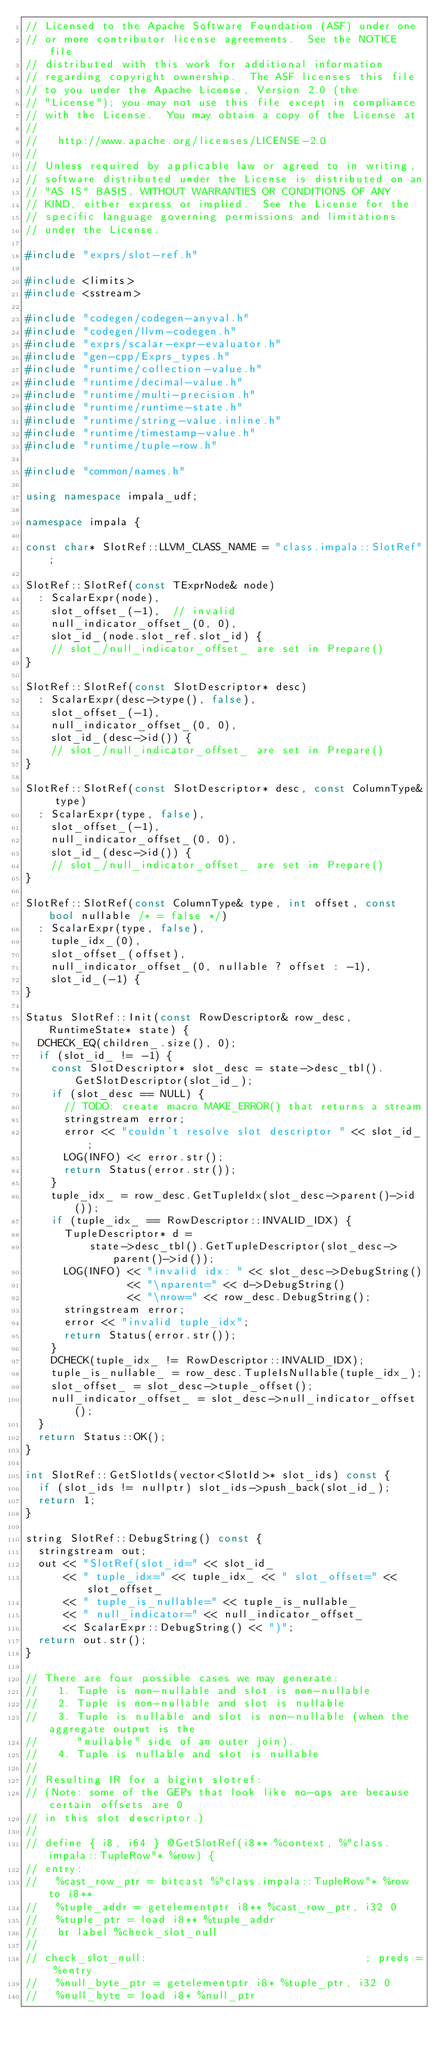<code> <loc_0><loc_0><loc_500><loc_500><_C++_>// Licensed to the Apache Software Foundation (ASF) under one
// or more contributor license agreements.  See the NOTICE file
// distributed with this work for additional information
// regarding copyright ownership.  The ASF licenses this file
// to you under the Apache License, Version 2.0 (the
// "License"); you may not use this file except in compliance
// with the License.  You may obtain a copy of the License at
//
//   http://www.apache.org/licenses/LICENSE-2.0
//
// Unless required by applicable law or agreed to in writing,
// software distributed under the License is distributed on an
// "AS IS" BASIS, WITHOUT WARRANTIES OR CONDITIONS OF ANY
// KIND, either express or implied.  See the License for the
// specific language governing permissions and limitations
// under the License.

#include "exprs/slot-ref.h"

#include <limits>
#include <sstream>

#include "codegen/codegen-anyval.h"
#include "codegen/llvm-codegen.h"
#include "exprs/scalar-expr-evaluator.h"
#include "gen-cpp/Exprs_types.h"
#include "runtime/collection-value.h"
#include "runtime/decimal-value.h"
#include "runtime/multi-precision.h"
#include "runtime/runtime-state.h"
#include "runtime/string-value.inline.h"
#include "runtime/timestamp-value.h"
#include "runtime/tuple-row.h"

#include "common/names.h"

using namespace impala_udf;

namespace impala {

const char* SlotRef::LLVM_CLASS_NAME = "class.impala::SlotRef";

SlotRef::SlotRef(const TExprNode& node)
  : ScalarExpr(node),
    slot_offset_(-1),  // invalid
    null_indicator_offset_(0, 0),
    slot_id_(node.slot_ref.slot_id) {
    // slot_/null_indicator_offset_ are set in Prepare()
}

SlotRef::SlotRef(const SlotDescriptor* desc)
  : ScalarExpr(desc->type(), false),
    slot_offset_(-1),
    null_indicator_offset_(0, 0),
    slot_id_(desc->id()) {
    // slot_/null_indicator_offset_ are set in Prepare()
}

SlotRef::SlotRef(const SlotDescriptor* desc, const ColumnType& type)
  : ScalarExpr(type, false),
    slot_offset_(-1),
    null_indicator_offset_(0, 0),
    slot_id_(desc->id()) {
    // slot_/null_indicator_offset_ are set in Prepare()
}

SlotRef::SlotRef(const ColumnType& type, int offset, const bool nullable /* = false */)
  : ScalarExpr(type, false),
    tuple_idx_(0),
    slot_offset_(offset),
    null_indicator_offset_(0, nullable ? offset : -1),
    slot_id_(-1) {
}

Status SlotRef::Init(const RowDescriptor& row_desc, RuntimeState* state) {
  DCHECK_EQ(children_.size(), 0);
  if (slot_id_ != -1) {
    const SlotDescriptor* slot_desc = state->desc_tbl().GetSlotDescriptor(slot_id_);
    if (slot_desc == NULL) {
      // TODO: create macro MAKE_ERROR() that returns a stream
      stringstream error;
      error << "couldn't resolve slot descriptor " << slot_id_;
      LOG(INFO) << error.str();
      return Status(error.str());
    }
    tuple_idx_ = row_desc.GetTupleIdx(slot_desc->parent()->id());
    if (tuple_idx_ == RowDescriptor::INVALID_IDX) {
      TupleDescriptor* d =
          state->desc_tbl().GetTupleDescriptor(slot_desc->parent()->id());
      LOG(INFO) << "invalid idx: " << slot_desc->DebugString()
                << "\nparent=" << d->DebugString()
                << "\nrow=" << row_desc.DebugString();
      stringstream error;
      error << "invalid tuple_idx";
      return Status(error.str());
    }
    DCHECK(tuple_idx_ != RowDescriptor::INVALID_IDX);
    tuple_is_nullable_ = row_desc.TupleIsNullable(tuple_idx_);
    slot_offset_ = slot_desc->tuple_offset();
    null_indicator_offset_ = slot_desc->null_indicator_offset();
  }
  return Status::OK();
}

int SlotRef::GetSlotIds(vector<SlotId>* slot_ids) const {
  if (slot_ids != nullptr) slot_ids->push_back(slot_id_);
  return 1;
}

string SlotRef::DebugString() const {
  stringstream out;
  out << "SlotRef(slot_id=" << slot_id_
      << " tuple_idx=" << tuple_idx_ << " slot_offset=" << slot_offset_
      << " tuple_is_nullable=" << tuple_is_nullable_
      << " null_indicator=" << null_indicator_offset_
      << ScalarExpr::DebugString() << ")";
  return out.str();
}

// There are four possible cases we may generate:
//   1. Tuple is non-nullable and slot is non-nullable
//   2. Tuple is non-nullable and slot is nullable
//   3. Tuple is nullable and slot is non-nullable (when the aggregate output is the
//      "nullable" side of an outer join).
//   4. Tuple is nullable and slot is nullable
//
// Resulting IR for a bigint slotref:
// (Note: some of the GEPs that look like no-ops are because certain offsets are 0
// in this slot descriptor.)
//
// define { i8, i64 } @GetSlotRef(i8** %context, %"class.impala::TupleRow"* %row) {
// entry:
//   %cast_row_ptr = bitcast %"class.impala::TupleRow"* %row to i8**
//   %tuple_addr = getelementptr i8** %cast_row_ptr, i32 0
//   %tuple_ptr = load i8** %tuple_addr
//   br label %check_slot_null
//
// check_slot_null:                                  ; preds = %entry
//   %null_byte_ptr = getelementptr i8* %tuple_ptr, i32 0
//   %null_byte = load i8* %null_ptr</code> 